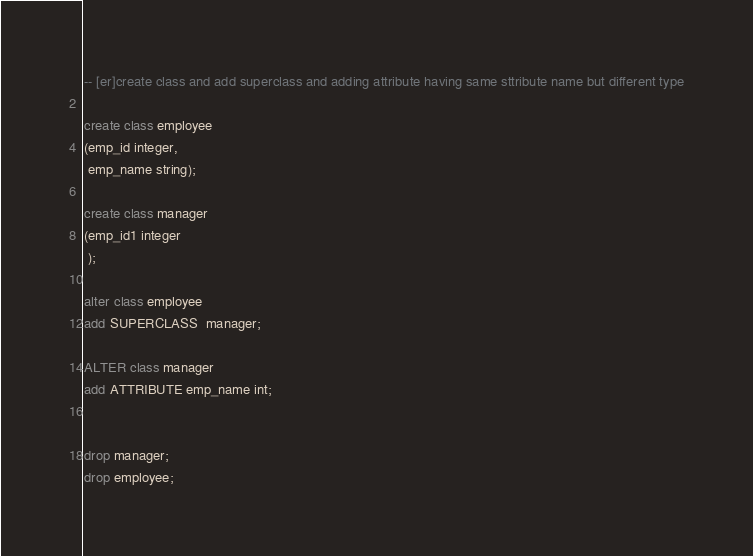<code> <loc_0><loc_0><loc_500><loc_500><_SQL_>-- [er]create class and add superclass and adding attribute having same sttribute name but different type

create class employee
(emp_id integer,
 emp_name string);

create class manager
(emp_id1 integer
 );

alter class employee
add SUPERCLASS  manager;

ALTER class manager
add ATTRIBUTE emp_name int;


drop manager;
drop employee;
</code> 